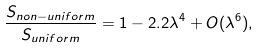<formula> <loc_0><loc_0><loc_500><loc_500>\frac { S _ { n o n - u n i f o r m } } { S _ { u n i f o r m } } = 1 - 2 . 2 \lambda ^ { 4 } + O ( \lambda ^ { 6 } ) ,</formula> 